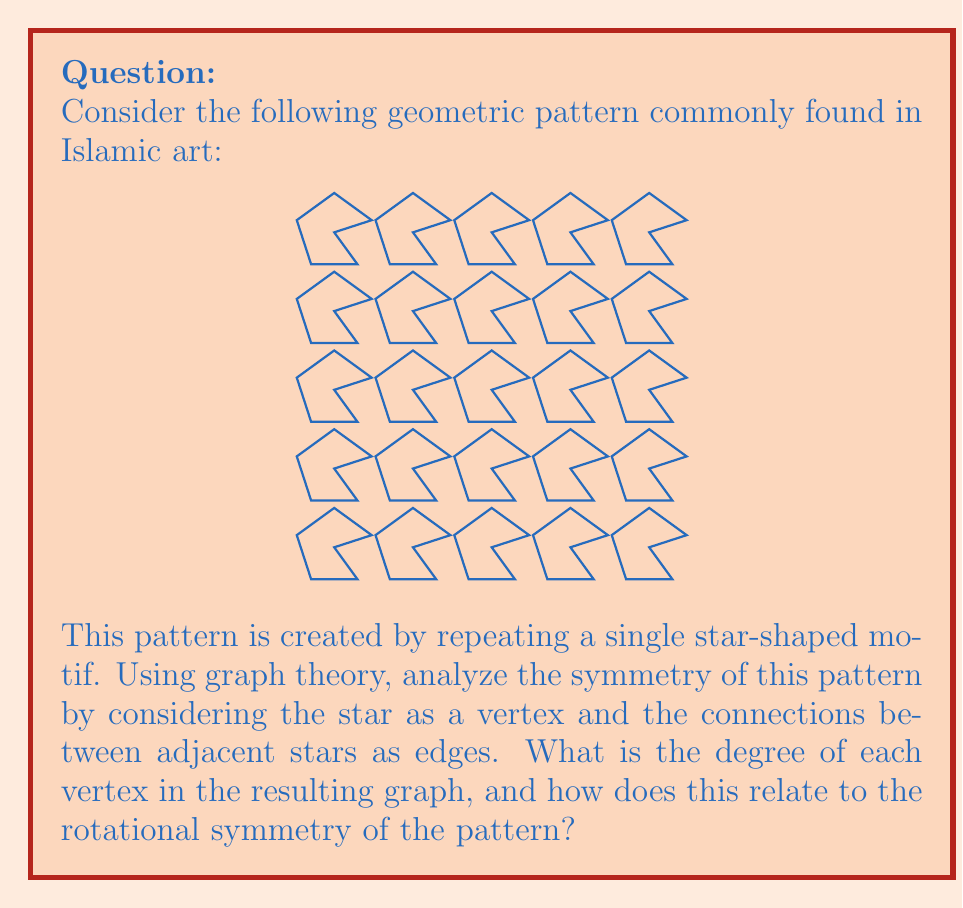What is the answer to this math problem? Let's approach this step-by-step:

1) First, we need to understand how the graph is constructed from the pattern:
   - Each star in the pattern becomes a vertex in our graph.
   - Edges are drawn between vertices that represent adjacent stars in the pattern.

2) Looking at the pattern, we can see that each star is surrounded by 6 other stars:
   - 4 stars at the corners (diagonal connections)
   - 2 stars at the sides (horizontal and vertical connections)

3) In graph theory, the degree of a vertex is the number of edges connected to it. In this case, the degree of each vertex is 6, corresponding to the 6 adjacent stars.

4) The degree of the vertices relates to the rotational symmetry of the pattern as follows:
   - The pattern has 6-fold rotational symmetry around the center of each star.
   - This means that rotating the pattern by 60° (360°/6) around the center of any star will produce an identical configuration.

5) In graph theory terms:
   - The graph created from this pattern is 6-regular, meaning every vertex has degree 6.
   - This 6-regularity directly corresponds to the 6-fold rotational symmetry of the original pattern.

6) The relationship between the degree and rotational symmetry is not coincidental:
   - Each edge in the graph represents a direction of symmetry in the original pattern.
   - The number of edges (degree) equals the number of symmetric directions, which determines the fold of rotational symmetry.

Thus, the graph theoretical analysis reveals and confirms the underlying 6-fold rotational symmetry of the Islamic geometric pattern.
Answer: Degree: 6; Corresponds to 6-fold rotational symmetry 